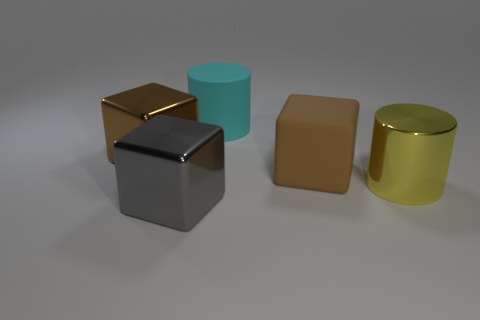Subtract all big metallic cubes. How many cubes are left? 1 Subtract all yellow cylinders. How many brown cubes are left? 2 Add 5 cylinders. How many objects exist? 10 Subtract 1 blocks. How many blocks are left? 2 Subtract all blocks. How many objects are left? 2 Subtract all yellow cubes. Subtract all green cylinders. How many cubes are left? 3 Subtract all shiny blocks. Subtract all blue rubber spheres. How many objects are left? 3 Add 2 shiny objects. How many shiny objects are left? 5 Add 3 large cyan matte objects. How many large cyan matte objects exist? 4 Subtract 0 cyan blocks. How many objects are left? 5 